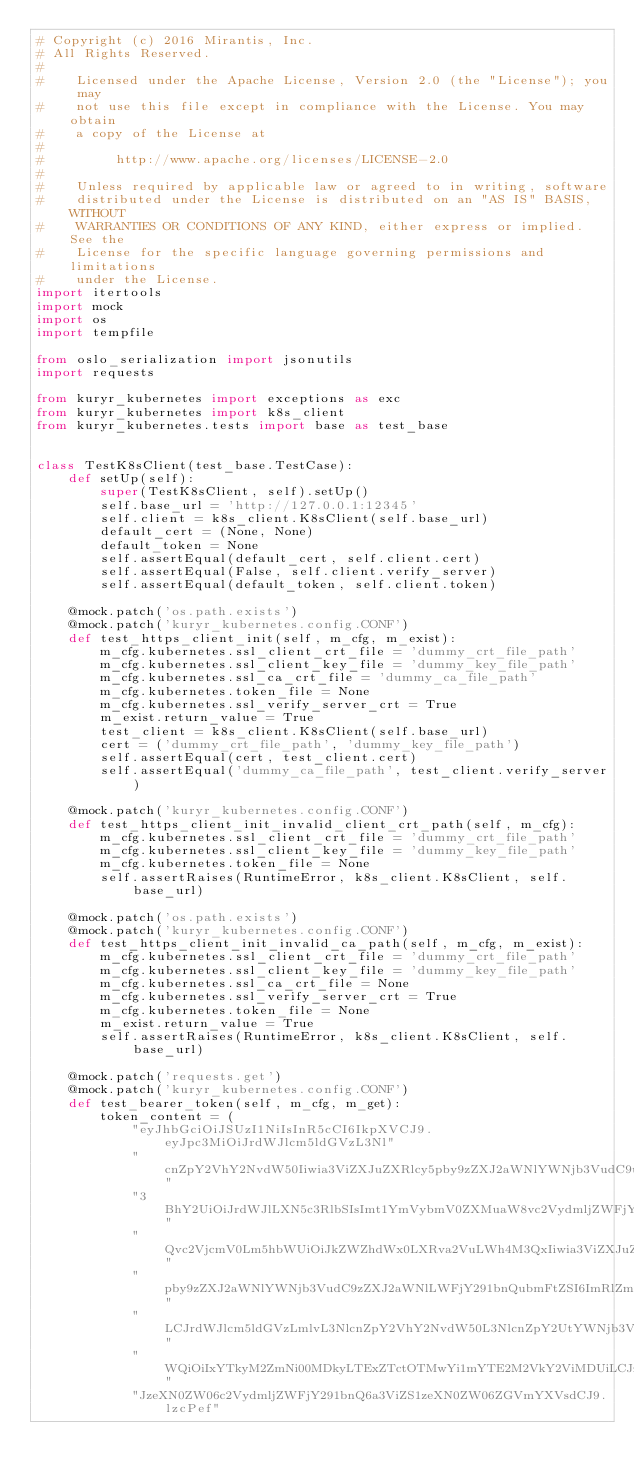<code> <loc_0><loc_0><loc_500><loc_500><_Python_># Copyright (c) 2016 Mirantis, Inc.
# All Rights Reserved.
#
#    Licensed under the Apache License, Version 2.0 (the "License"); you may
#    not use this file except in compliance with the License. You may obtain
#    a copy of the License at
#
#         http://www.apache.org/licenses/LICENSE-2.0
#
#    Unless required by applicable law or agreed to in writing, software
#    distributed under the License is distributed on an "AS IS" BASIS, WITHOUT
#    WARRANTIES OR CONDITIONS OF ANY KIND, either express or implied. See the
#    License for the specific language governing permissions and limitations
#    under the License.
import itertools
import mock
import os
import tempfile

from oslo_serialization import jsonutils
import requests

from kuryr_kubernetes import exceptions as exc
from kuryr_kubernetes import k8s_client
from kuryr_kubernetes.tests import base as test_base


class TestK8sClient(test_base.TestCase):
    def setUp(self):
        super(TestK8sClient, self).setUp()
        self.base_url = 'http://127.0.0.1:12345'
        self.client = k8s_client.K8sClient(self.base_url)
        default_cert = (None, None)
        default_token = None
        self.assertEqual(default_cert, self.client.cert)
        self.assertEqual(False, self.client.verify_server)
        self.assertEqual(default_token, self.client.token)

    @mock.patch('os.path.exists')
    @mock.patch('kuryr_kubernetes.config.CONF')
    def test_https_client_init(self, m_cfg, m_exist):
        m_cfg.kubernetes.ssl_client_crt_file = 'dummy_crt_file_path'
        m_cfg.kubernetes.ssl_client_key_file = 'dummy_key_file_path'
        m_cfg.kubernetes.ssl_ca_crt_file = 'dummy_ca_file_path'
        m_cfg.kubernetes.token_file = None
        m_cfg.kubernetes.ssl_verify_server_crt = True
        m_exist.return_value = True
        test_client = k8s_client.K8sClient(self.base_url)
        cert = ('dummy_crt_file_path', 'dummy_key_file_path')
        self.assertEqual(cert, test_client.cert)
        self.assertEqual('dummy_ca_file_path', test_client.verify_server)

    @mock.patch('kuryr_kubernetes.config.CONF')
    def test_https_client_init_invalid_client_crt_path(self, m_cfg):
        m_cfg.kubernetes.ssl_client_crt_file = 'dummy_crt_file_path'
        m_cfg.kubernetes.ssl_client_key_file = 'dummy_key_file_path'
        m_cfg.kubernetes.token_file = None
        self.assertRaises(RuntimeError, k8s_client.K8sClient, self.base_url)

    @mock.patch('os.path.exists')
    @mock.patch('kuryr_kubernetes.config.CONF')
    def test_https_client_init_invalid_ca_path(self, m_cfg, m_exist):
        m_cfg.kubernetes.ssl_client_crt_file = 'dummy_crt_file_path'
        m_cfg.kubernetes.ssl_client_key_file = 'dummy_key_file_path'
        m_cfg.kubernetes.ssl_ca_crt_file = None
        m_cfg.kubernetes.ssl_verify_server_crt = True
        m_cfg.kubernetes.token_file = None
        m_exist.return_value = True
        self.assertRaises(RuntimeError, k8s_client.K8sClient, self.base_url)

    @mock.patch('requests.get')
    @mock.patch('kuryr_kubernetes.config.CONF')
    def test_bearer_token(self, m_cfg, m_get):
        token_content = (
            "eyJhbGciOiJSUzI1NiIsInR5cCI6IkpXVCJ9.eyJpc3MiOiJrdWJlcm5ldGVzL3Nl"
            "cnZpY2VhY2NvdW50Iiwia3ViZXJuZXRlcy5pby9zZXJ2aWNlYWNjb3VudC9uYW1lc"
            "3BhY2UiOiJrdWJlLXN5c3RlbSIsImt1YmVybmV0ZXMuaW8vc2VydmljZWFjY291bn"
            "Qvc2VjcmV0Lm5hbWUiOiJkZWZhdWx0LXRva2VuLWh4M3QxIiwia3ViZXJuZXRlcy5"
            "pby9zZXJ2aWNlYWNjb3VudC9zZXJ2aWNlLWFjY291bnQubmFtZSI6ImRlZmF1bHQi"
            "LCJrdWJlcm5ldGVzLmlvL3NlcnZpY2VhY2NvdW50L3NlcnZpY2UtYWNjb3VudC51a"
            "WQiOiIxYTkyM2ZmNi00MDkyLTExZTctOTMwYi1mYTE2M2VkY2ViMDUiLCJzdWIiOi"
            "JzeXN0ZW06c2VydmljZWFjY291bnQ6a3ViZS1zeXN0ZW06ZGVmYXVsdCJ9.lzcPef"</code> 